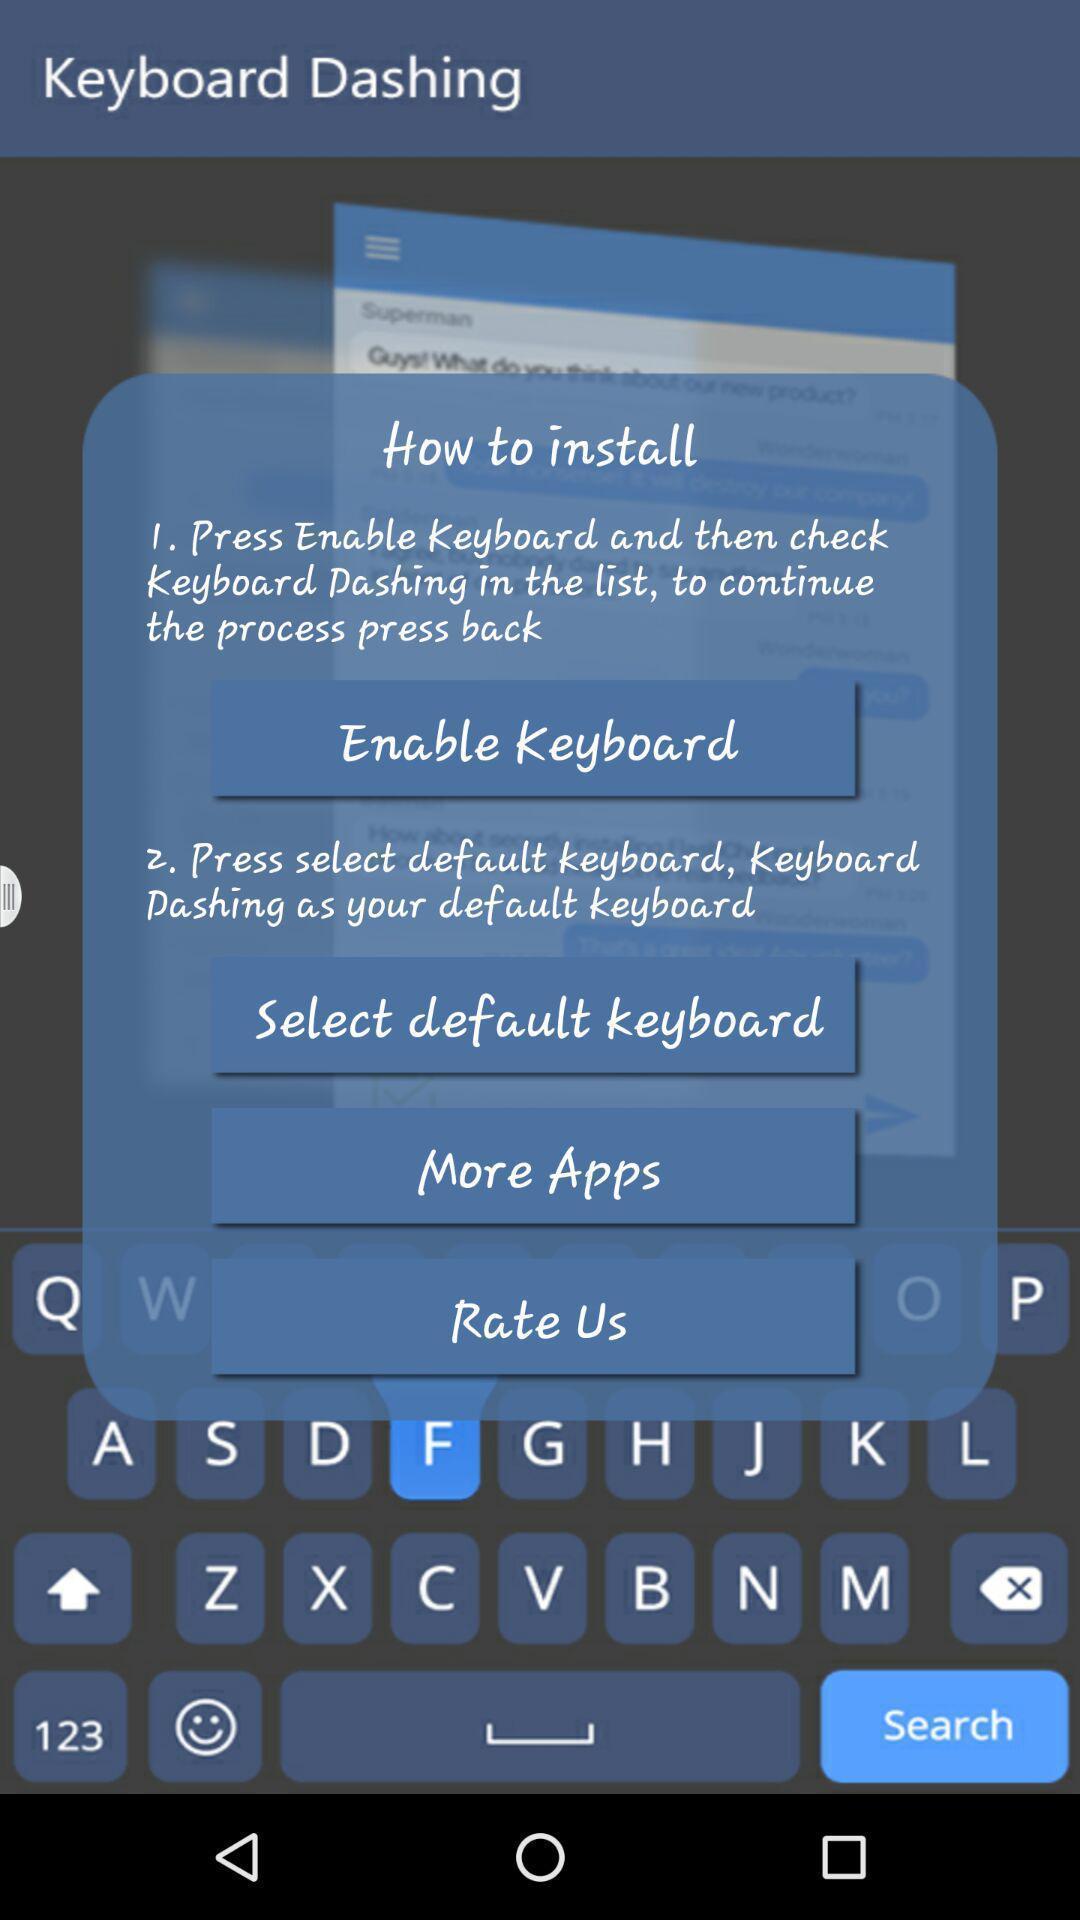Explain what's happening in this screen capture. Pop-up showing list of options. 